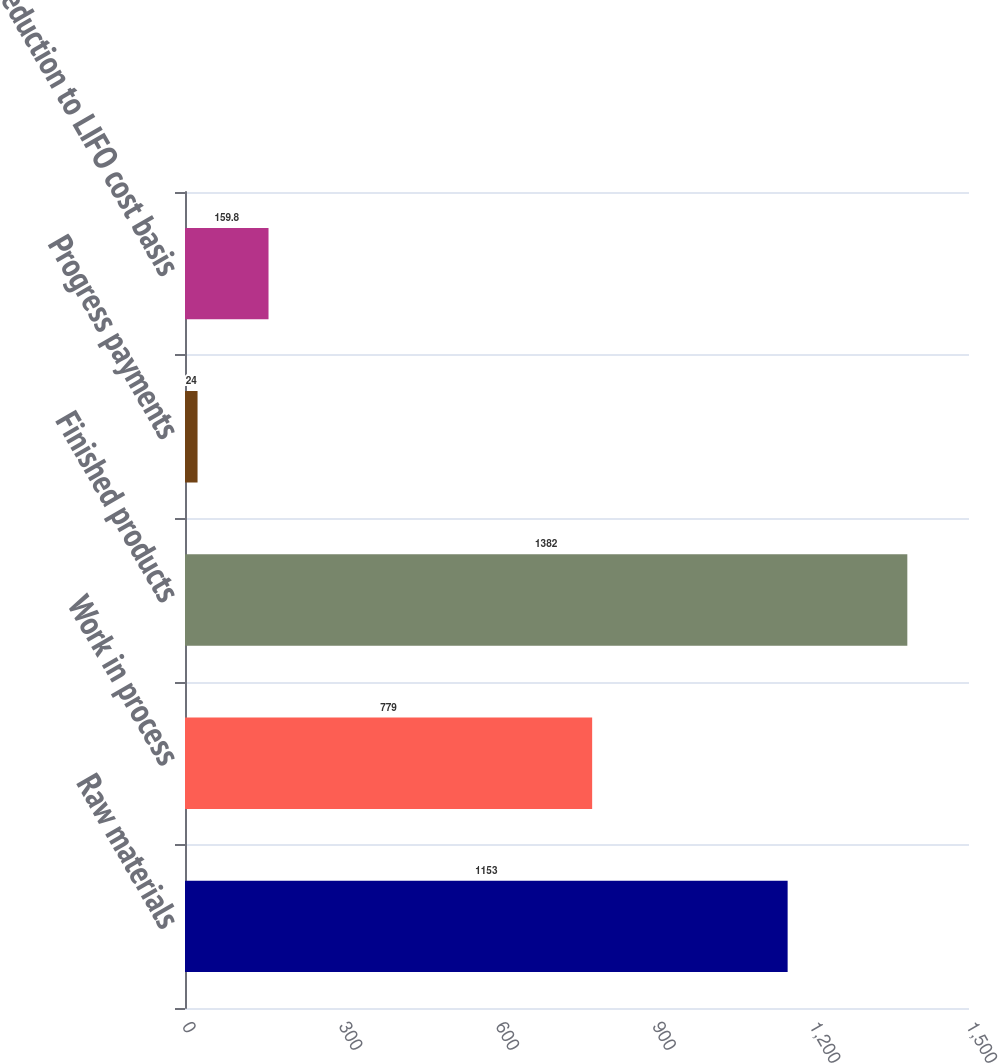Convert chart to OTSL. <chart><loc_0><loc_0><loc_500><loc_500><bar_chart><fcel>Raw materials<fcel>Work in process<fcel>Finished products<fcel>Progress payments<fcel>Reduction to LIFO cost basis<nl><fcel>1153<fcel>779<fcel>1382<fcel>24<fcel>159.8<nl></chart> 